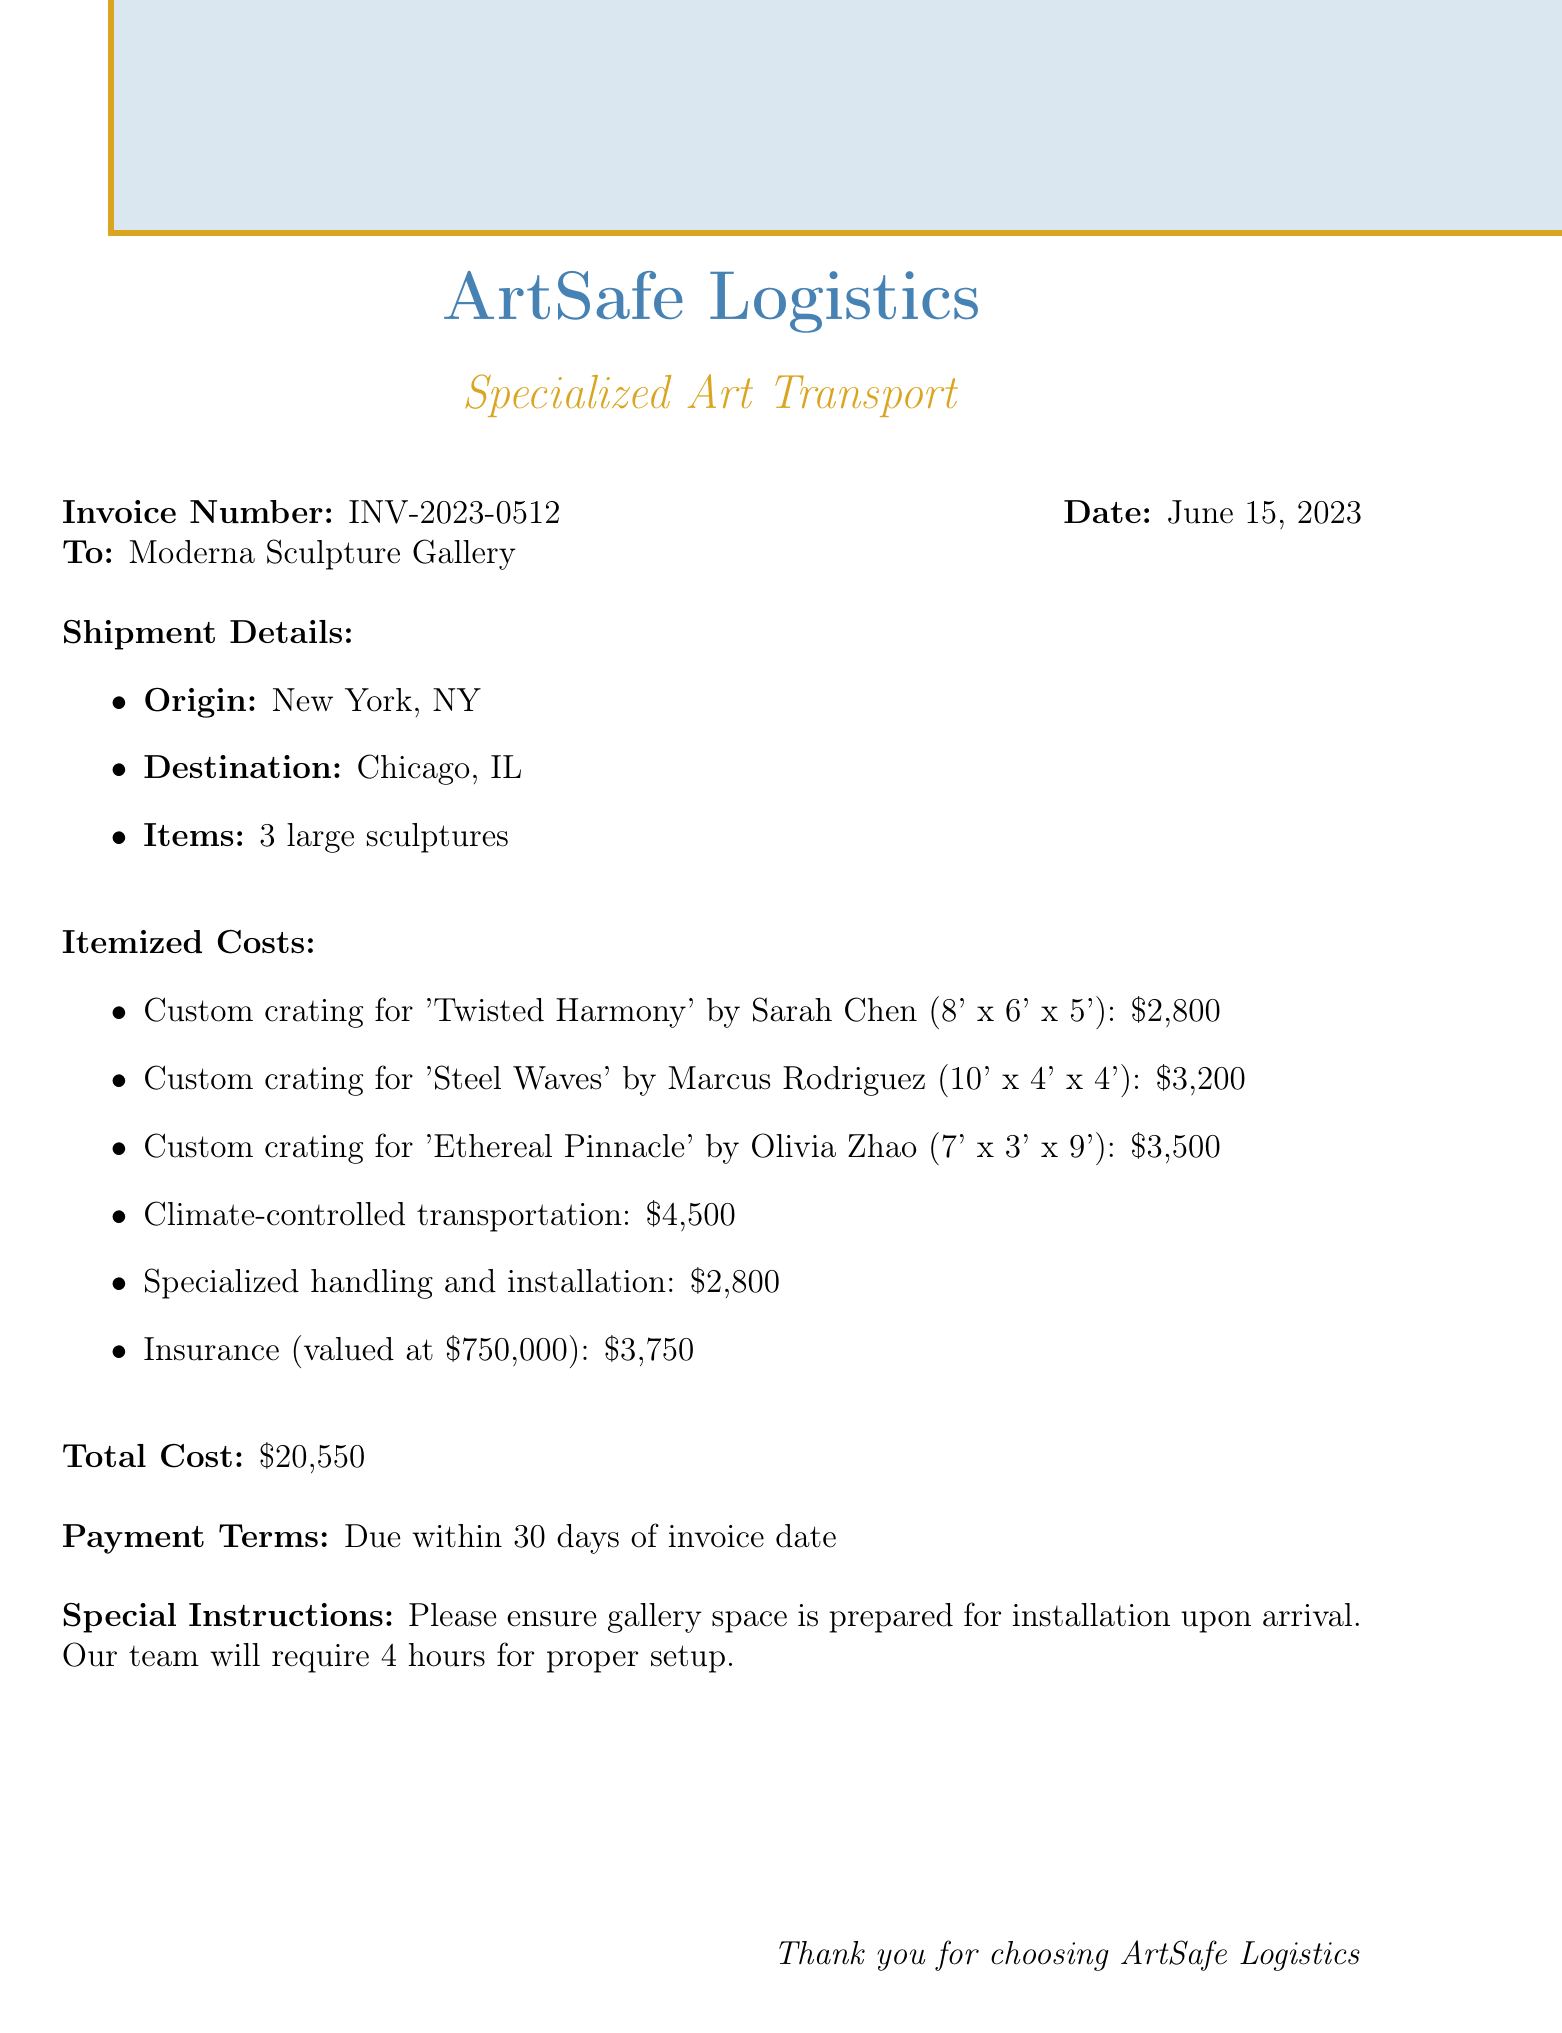What is the invoice number? The invoice number is listed at the top of the document as a unique identifier for this transaction.
Answer: INV-2023-0512 Who is the transport company? The transport company is mentioned prominently at the beginning of the document.
Answer: ArtSafe Logistics What is the total cost of the shipment? The total cost is clearly stated in the document as the sum of all itemized costs.
Answer: $20,550 How many sculptures are being transported? The number of sculptures is specified within the shipment details section.
Answer: 3 large sculptures What is the date of shipment? The date is clearly indicated in the shipment details section of the invoice.
Answer: June 15, 2023 What city is the origin of the shipment? The origin of the shipment is part of the shipment details mentioned in the document.
Answer: New York, NY What is the cost of insurance? The cost of insurance is provided in the itemized costs section of the invoice.
Answer: $3,750 What special instructions are given for the installation? The special instructions provide specific details to ensure proper setup upon arrival.
Answer: Please ensure gallery space is prepared for installation upon arrival What is the payment term for the invoice? The payment terms are specified at the end of the document regarding when the payment is due.
Answer: Due within 30 days of invoice date 